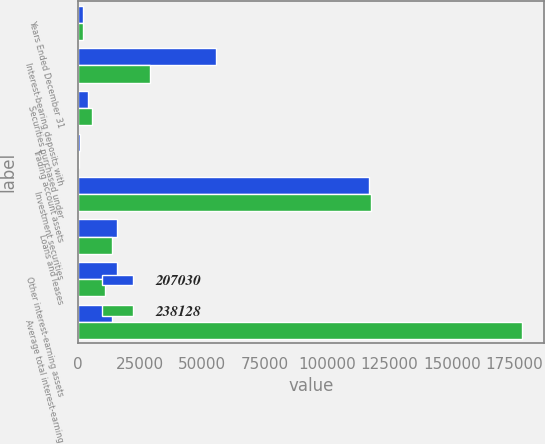<chart> <loc_0><loc_0><loc_500><loc_500><stacked_bar_chart><ecel><fcel>Years Ended December 31<fcel>Interest-bearing deposits with<fcel>Securities purchased under<fcel>Trading account assets<fcel>Investment securities<fcel>Loans and leases<fcel>Other interest-earning assets<fcel>Average total interest-earning<nl><fcel>207030<fcel>2014<fcel>55353<fcel>4077<fcel>959<fcel>116809<fcel>15912<fcel>15944<fcel>13781<nl><fcel>238128<fcel>2013<fcel>28946<fcel>5766<fcel>748<fcel>117696<fcel>13781<fcel>11164<fcel>178101<nl></chart> 